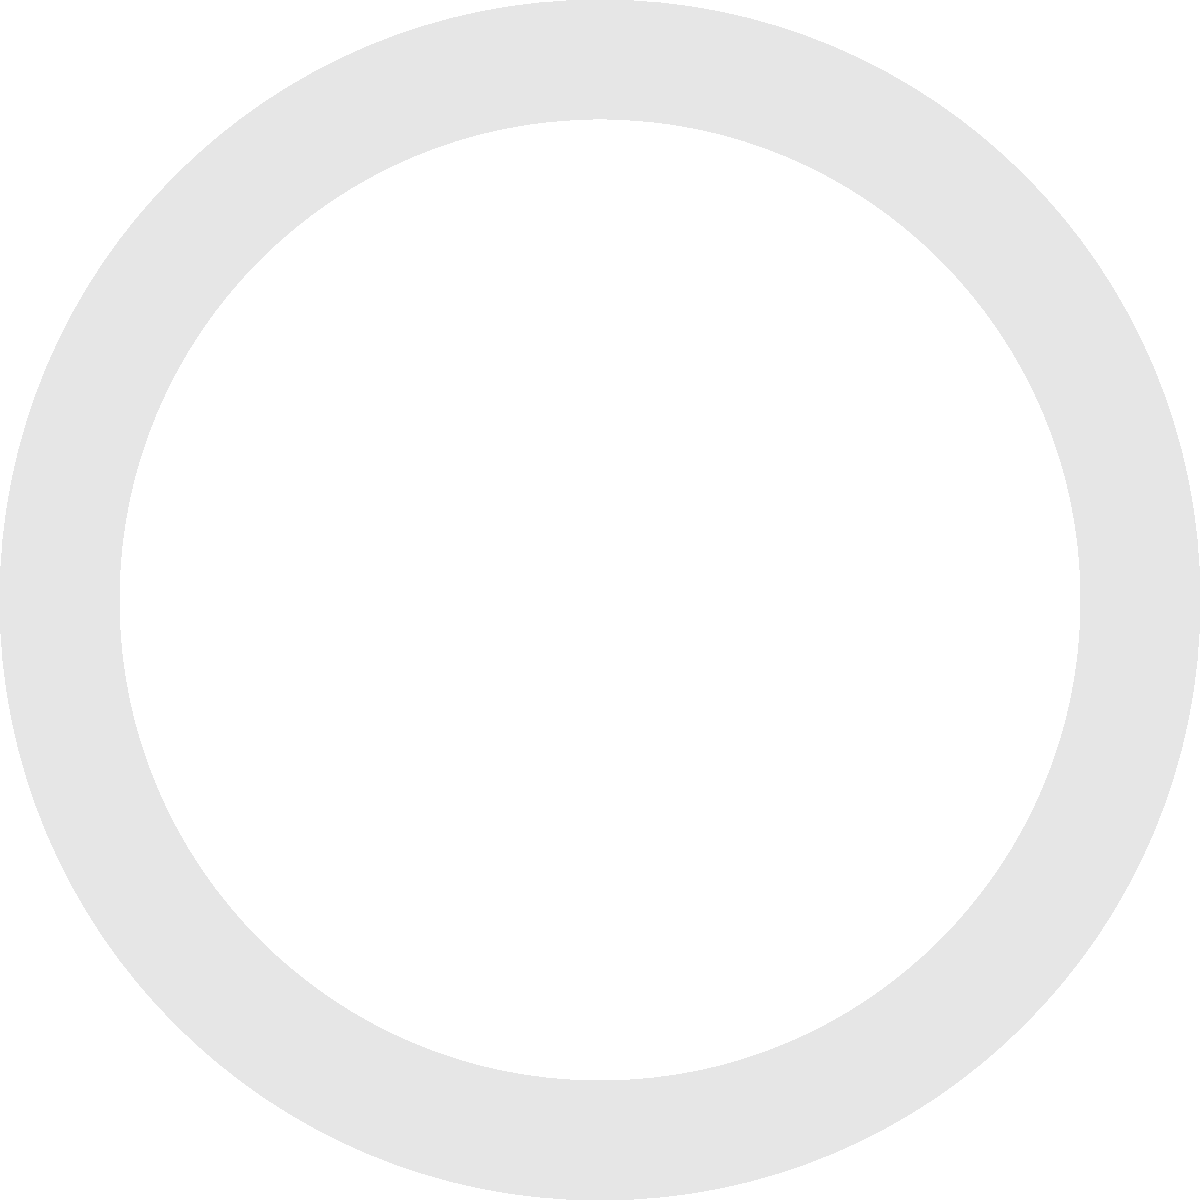You've intercepted an encrypted financial message: "23-15-12-12-15-23 20-8-5 13-15-14-5-25". Using the cipher wheel shown, where 'A' aligns with '1', decode the message. What action does it instruct? To decode the message using the cipher wheel, we follow these steps:

1. The cipher wheel shows the outer ring with letters A-Z and the inner ring with numbers 1-26.
2. The alignment shows 'A' corresponding to '1'.
3. We need to convert each number in the message to its corresponding letter.

Let's decode the message step by step:

23 → W
15 → O
12 → L
12 → L
15 → O
23 → W

20 → T
8 → H
5 → E

13 → M
15 → O
14 → N
5 → E
25 → Y

The decoded message reads: "WOLLOW THE MONEY"

However, we can infer that there's a small error in the encoding, and the first word should be "FOLLOW" instead of "WOLLOW".

Therefore, the decoded message is: "FOLLOW THE MONEY"

This is a common phrase used in financial investigations, instructing investigators to trace the flow of funds to uncover illegal activities or the true nature of transactions.
Answer: FOLLOW THE MONEY 